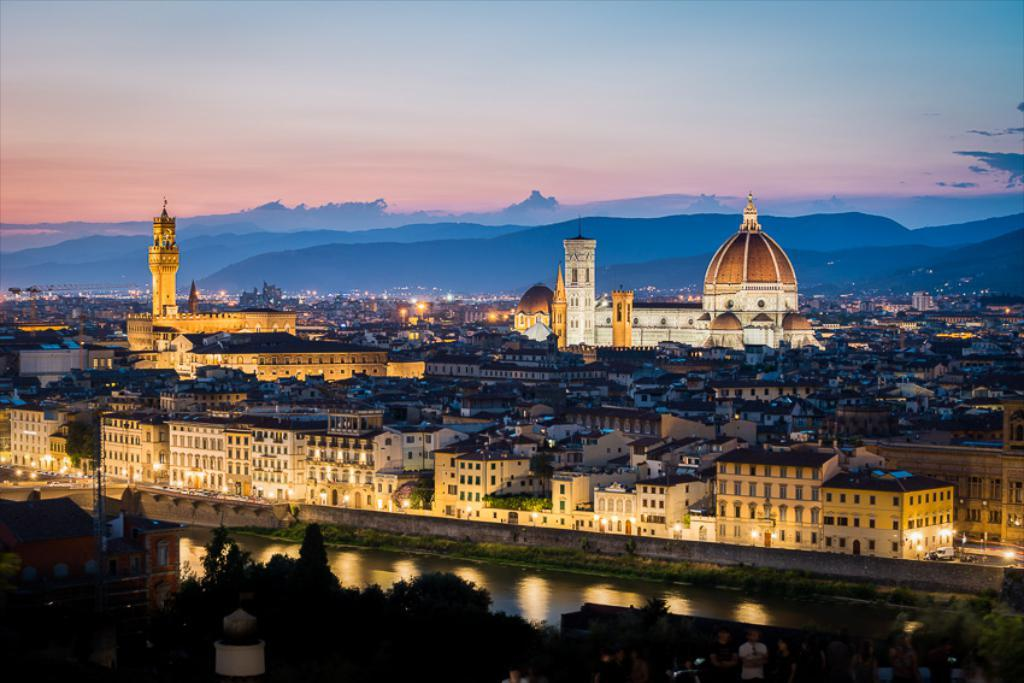What is located in the center of the image? There are buildings in the center of the image. What is at the bottom of the image? There is a canal at the bottom of the image. What type of vegetation can be seen in the image? Trees are visible in the image. What can be seen in the background of the image? There are hills and the sky visible in the background of the image. What type of book is the minister reading on the train in the image? There is no minister, book, or train present in the image. 